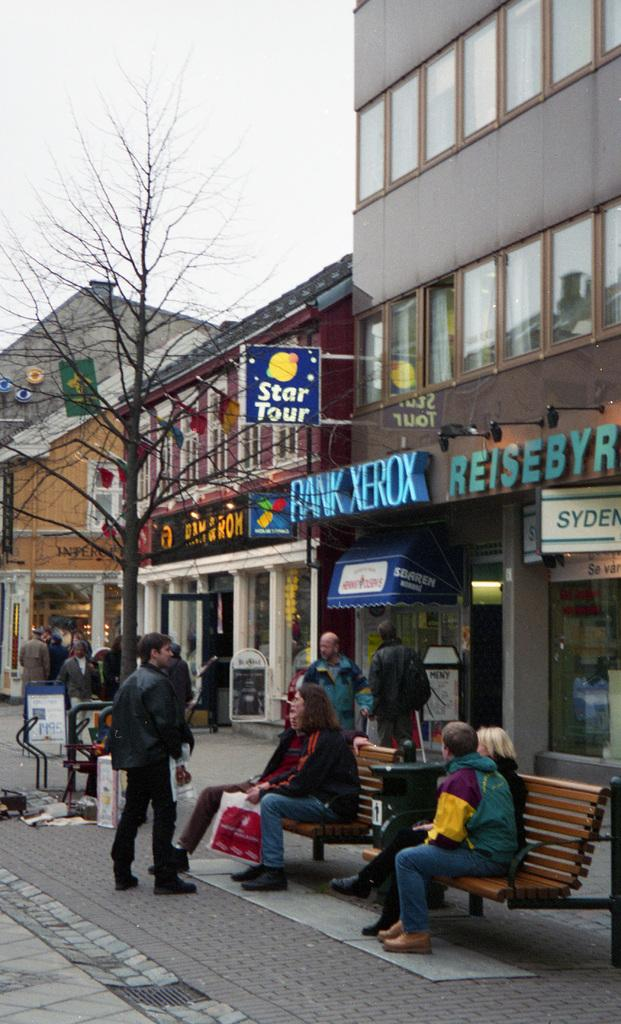What are the people in the image doing? There are persons sitting in the image, and some are standing in the background. What can be seen in the background of the image? There is a tree, a stall, a building, a window, and the sky visible in the background. How many people are sitting in the image? The number of people sitting in the image cannot be determined from the provided facts. What type of cracker is being used to carry the basket in the image? There is no cracker or basket present in the image. What day of the week is depicted in the image? The day of the week is not mentioned or depicted in the image. 